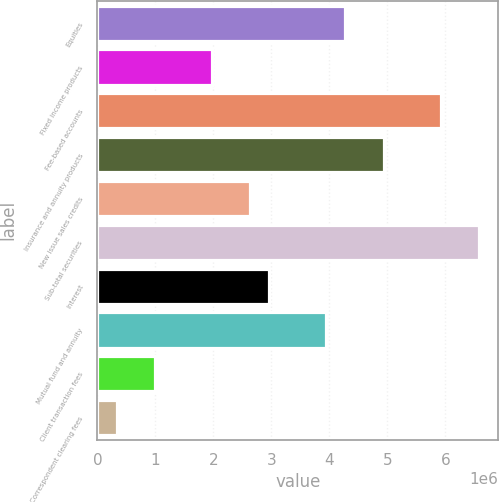Convert chart. <chart><loc_0><loc_0><loc_500><loc_500><bar_chart><fcel>Equities<fcel>Fixed income products<fcel>Fee-based accounts<fcel>Insurance and annuity products<fcel>New issue sales credits<fcel>Sub-total securities<fcel>Interest<fcel>Mutual fund and annuity<fcel>Client transaction fees<fcel>Correspondent clearing fees<nl><fcel>4.27627e+06<fcel>1.97382e+06<fcel>5.92087e+06<fcel>4.93411e+06<fcel>2.63166e+06<fcel>6.57871e+06<fcel>2.96058e+06<fcel>3.94734e+06<fcel>987056<fcel>329214<nl></chart> 